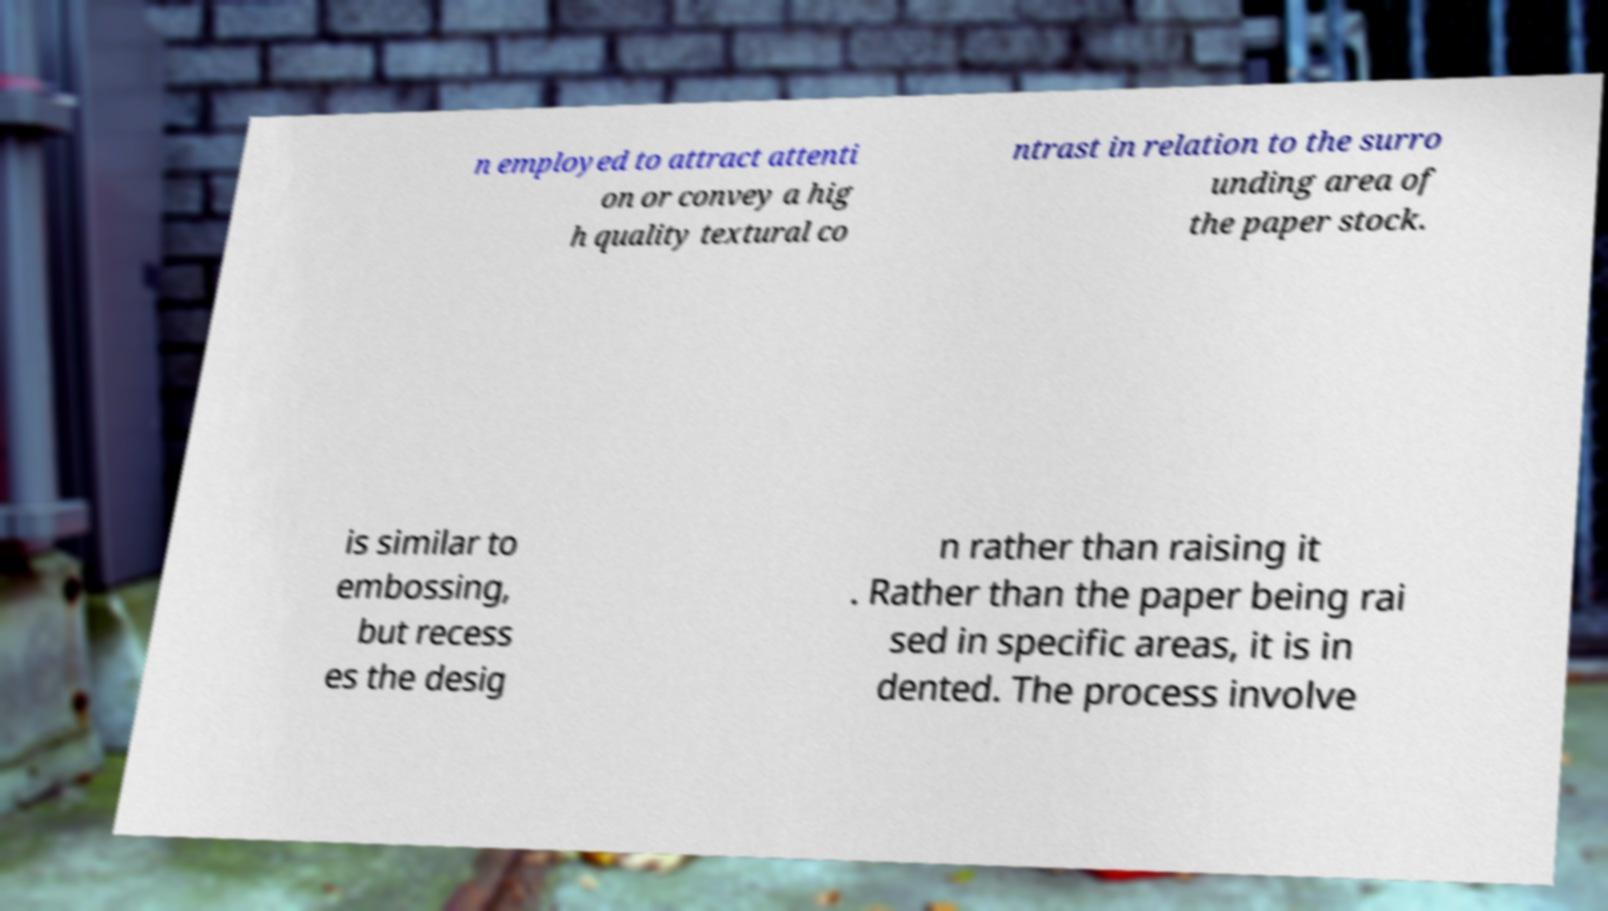I need the written content from this picture converted into text. Can you do that? n employed to attract attenti on or convey a hig h quality textural co ntrast in relation to the surro unding area of the paper stock. is similar to embossing, but recess es the desig n rather than raising it . Rather than the paper being rai sed in specific areas, it is in dented. The process involve 